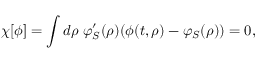<formula> <loc_0><loc_0><loc_500><loc_500>\chi [ \phi ] = \int d \rho \, \varphi _ { S } ^ { \prime } ( \rho ) ( \phi ( t , \rho ) - \varphi _ { S } ( \rho ) ) = 0 ,</formula> 